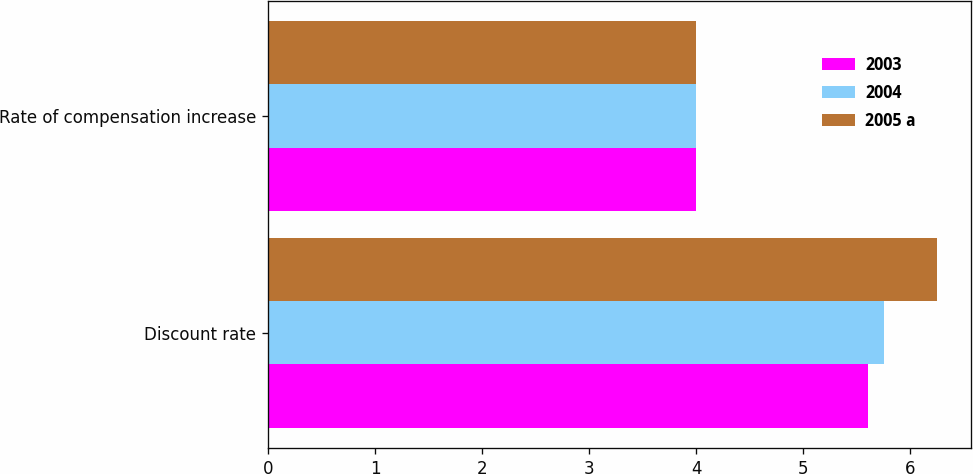Convert chart. <chart><loc_0><loc_0><loc_500><loc_500><stacked_bar_chart><ecel><fcel>Discount rate<fcel>Rate of compensation increase<nl><fcel>2003<fcel>5.6<fcel>4<nl><fcel>2004<fcel>5.75<fcel>4<nl><fcel>2005 a<fcel>6.25<fcel>4<nl></chart> 